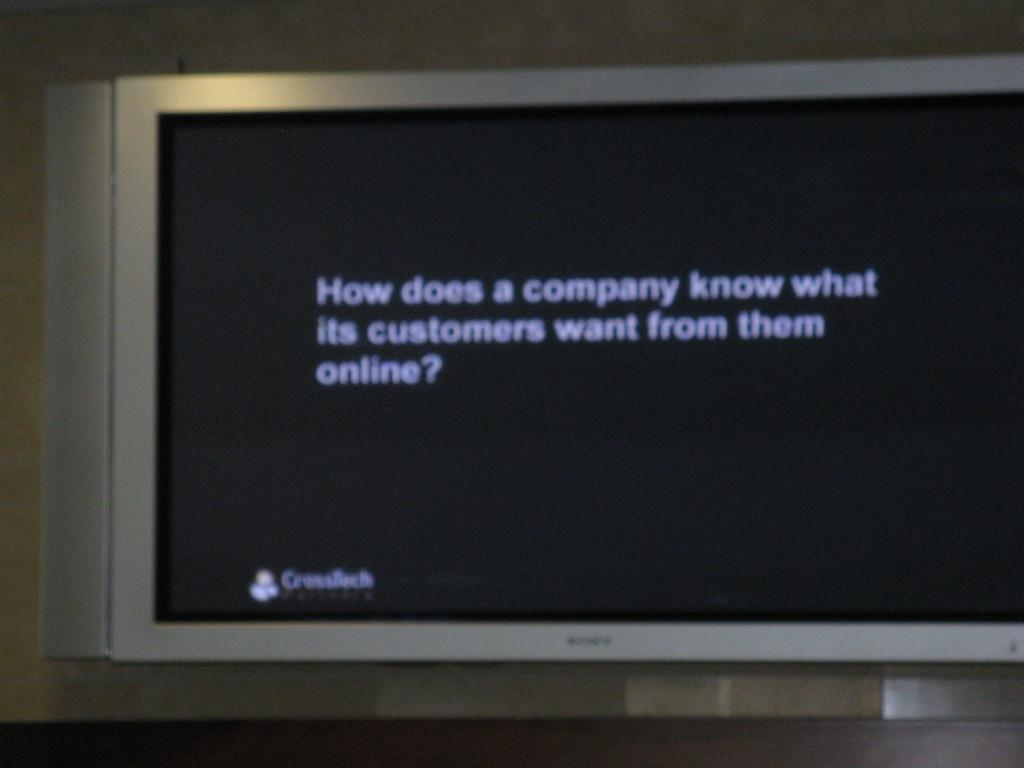Provide a one-sentence caption for the provided image. A large tv that says how does a company know what its customers want. 